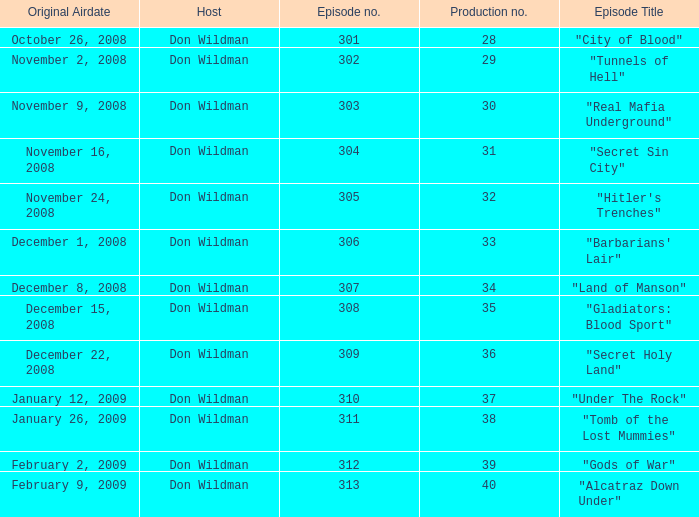What is the episode number of the episode that originally aired on January 26, 2009 and had a production number smaller than 38? 0.0. 